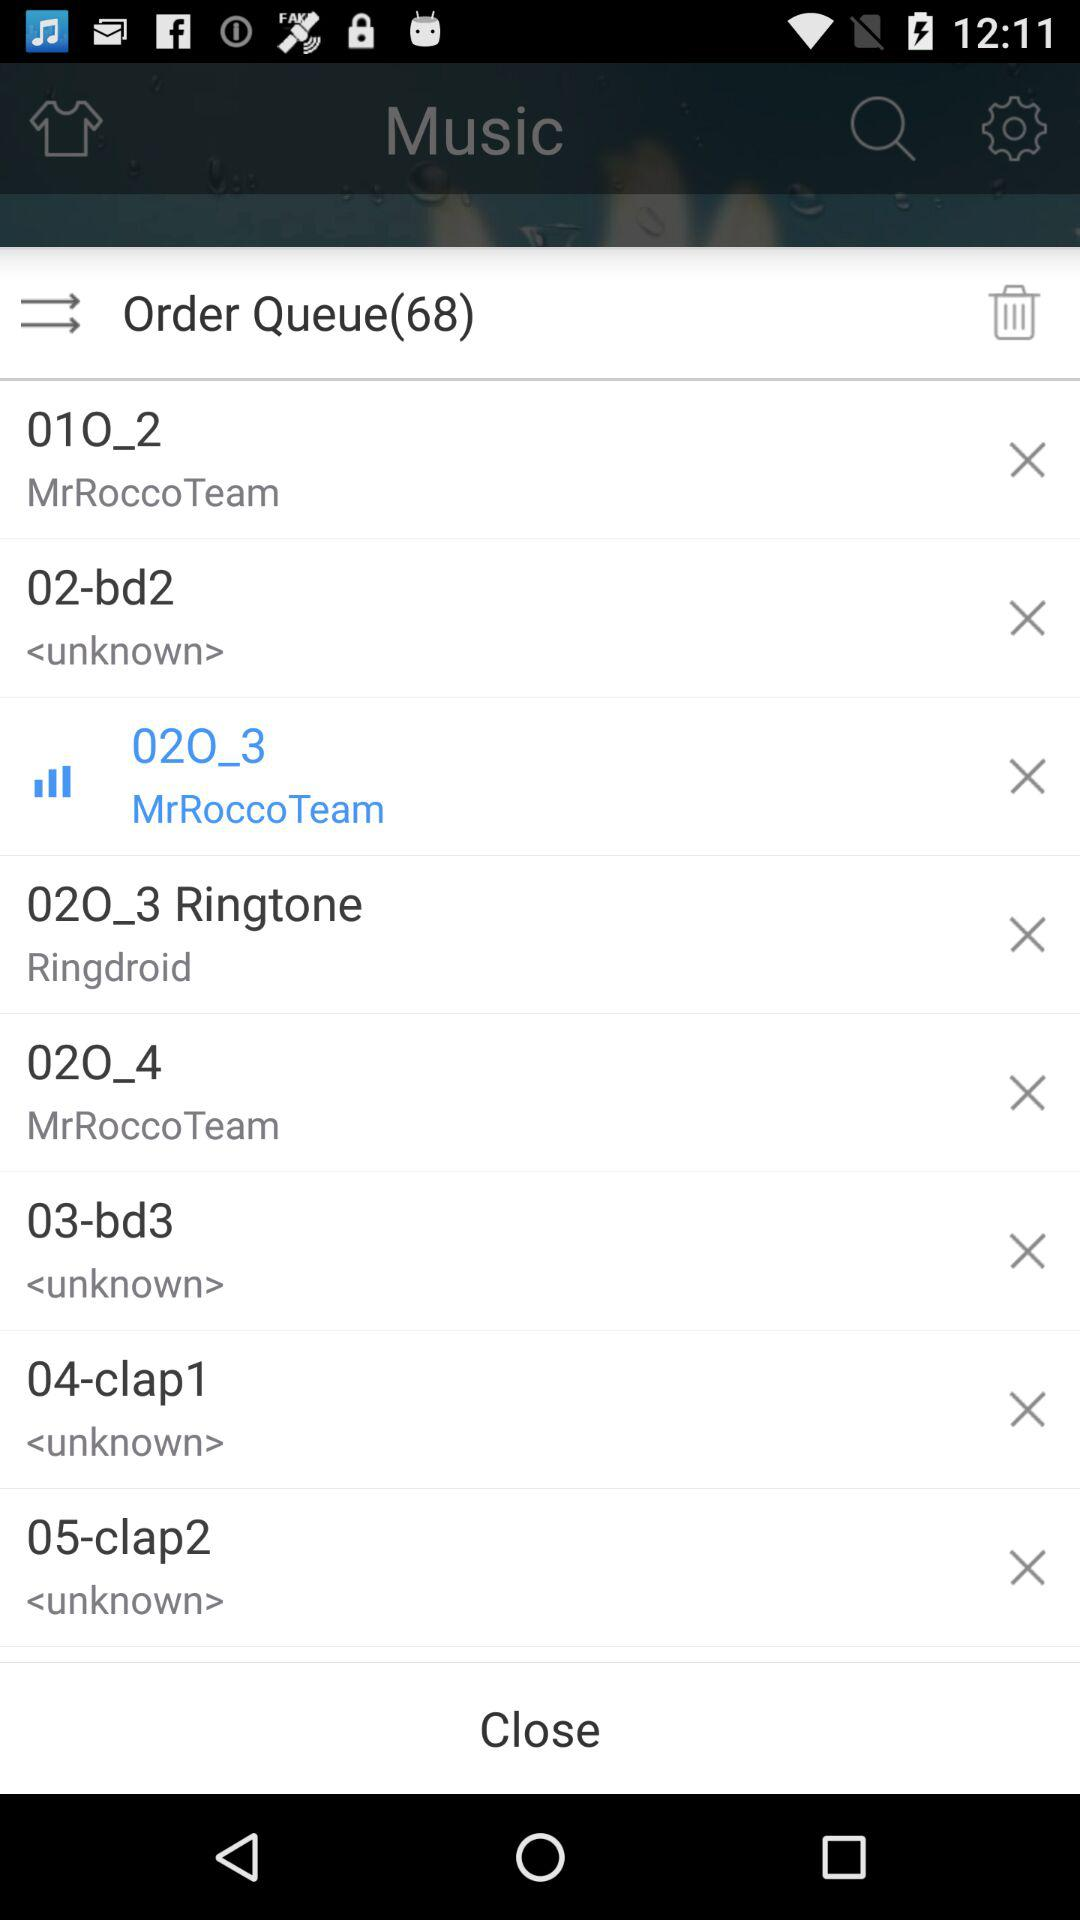What song is playing? The song is "02O_3". 